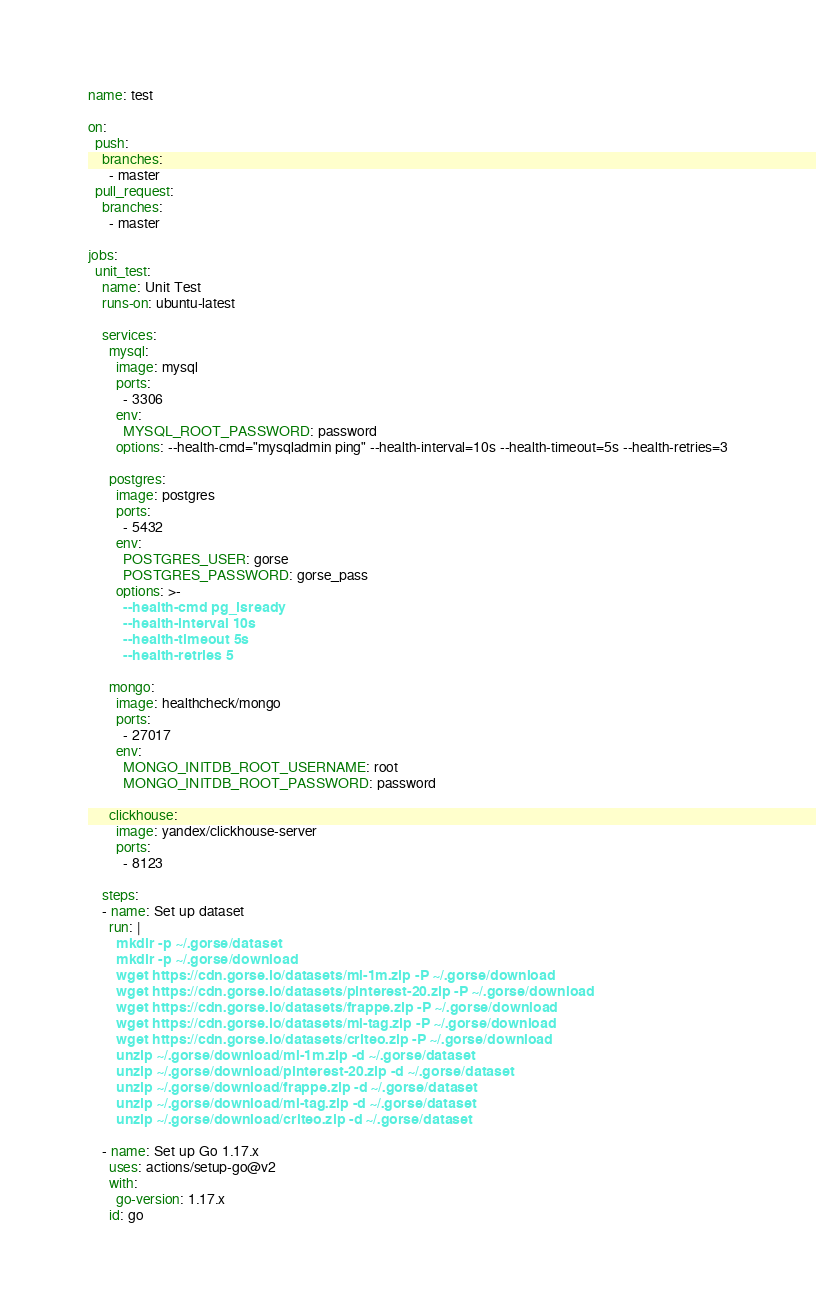Convert code to text. <code><loc_0><loc_0><loc_500><loc_500><_YAML_>name: test

on:
  push:
    branches:    
      - master
  pull_request:
    branches:    
      - master

jobs:
  unit_test:
    name: Unit Test
    runs-on: ubuntu-latest

    services:
      mysql:
        image: mysql
        ports:
          - 3306
        env:
          MYSQL_ROOT_PASSWORD: password
        options: --health-cmd="mysqladmin ping" --health-interval=10s --health-timeout=5s --health-retries=3

      postgres:
        image: postgres
        ports:
          - 5432
        env:
          POSTGRES_USER: gorse
          POSTGRES_PASSWORD: gorse_pass
        options: >-
          --health-cmd pg_isready
          --health-interval 10s
          --health-timeout 5s
          --health-retries 5

      mongo:
        image: healthcheck/mongo
        ports:
          - 27017
        env:
          MONGO_INITDB_ROOT_USERNAME: root
          MONGO_INITDB_ROOT_PASSWORD: password

      clickhouse:
        image: yandex/clickhouse-server
        ports:
          - 8123

    steps:
    - name: Set up dataset
      run: |
        mkdir -p ~/.gorse/dataset
        mkdir -p ~/.gorse/download
        wget https://cdn.gorse.io/datasets/ml-1m.zip -P ~/.gorse/download
        wget https://cdn.gorse.io/datasets/pinterest-20.zip -P ~/.gorse/download
        wget https://cdn.gorse.io/datasets/frappe.zip -P ~/.gorse/download
        wget https://cdn.gorse.io/datasets/ml-tag.zip -P ~/.gorse/download
        wget https://cdn.gorse.io/datasets/criteo.zip -P ~/.gorse/download
        unzip ~/.gorse/download/ml-1m.zip -d ~/.gorse/dataset
        unzip ~/.gorse/download/pinterest-20.zip -d ~/.gorse/dataset
        unzip ~/.gorse/download/frappe.zip -d ~/.gorse/dataset
        unzip ~/.gorse/download/ml-tag.zip -d ~/.gorse/dataset
        unzip ~/.gorse/download/criteo.zip -d ~/.gorse/dataset

    - name: Set up Go 1.17.x
      uses: actions/setup-go@v2
      with:
        go-version: 1.17.x
      id: go
</code> 